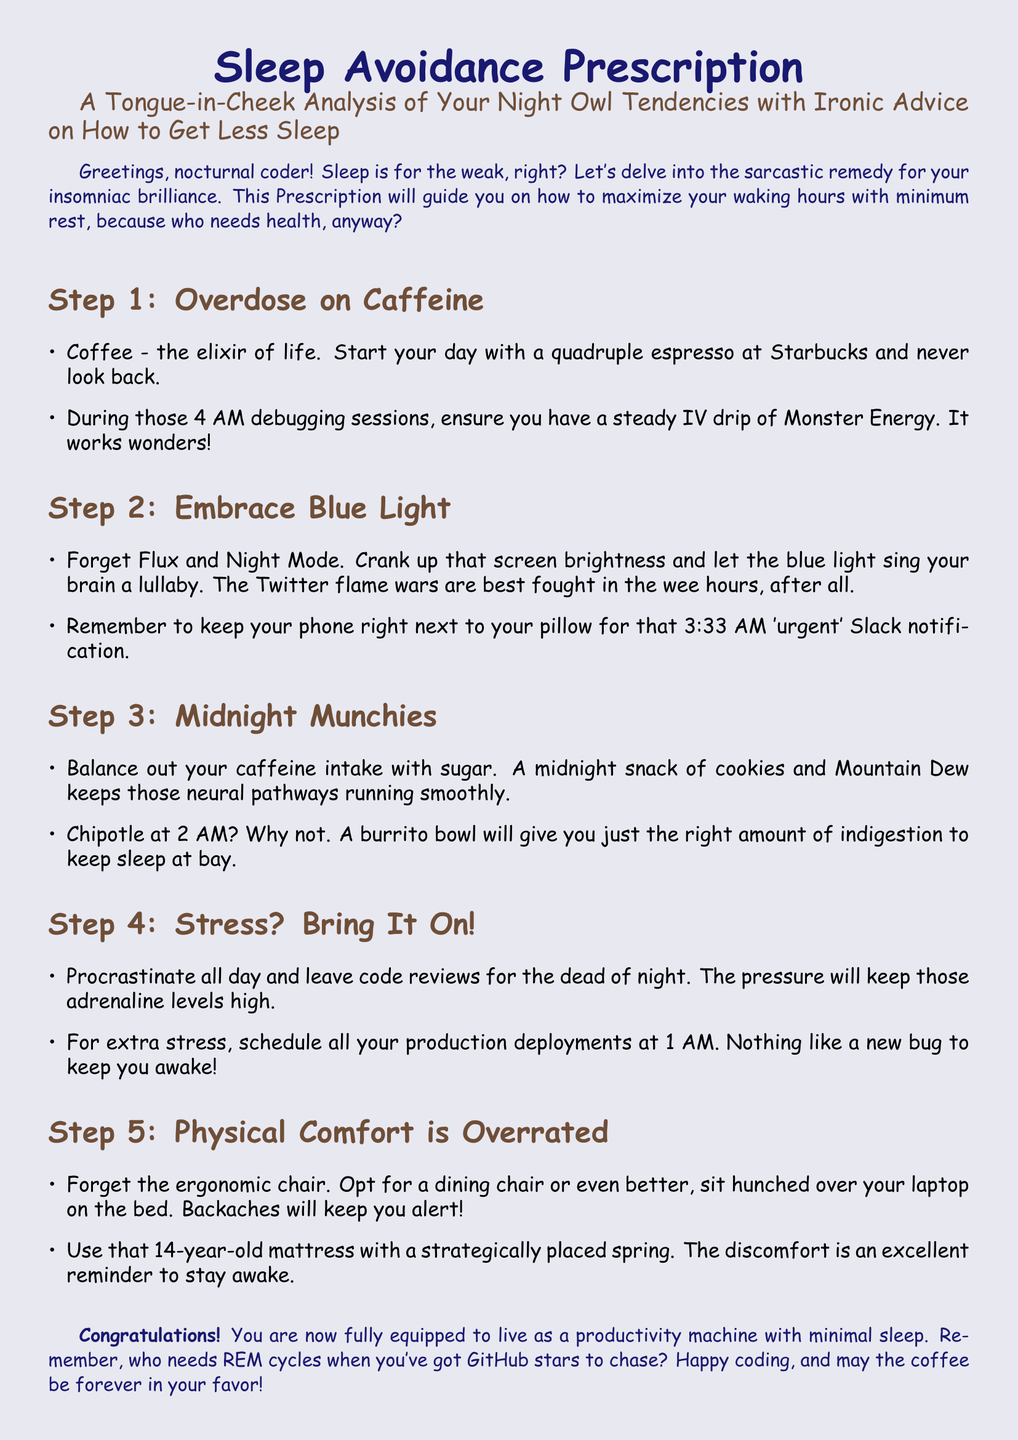What are the steps outlined in the prescription? The document outlines five steps for sleep avoidance: Overdose on Caffeine, Embrace Blue Light, Midnight Munchies, Stress? Bring It On!, and Physical Comfort is Overrated.
Answer: Five steps What is suggested as an ideal drink to start the day? The prescription humorously suggests starting the day with a quadruple espresso at Starbucks.
Answer: Quadruple espresso What type of light should you embrace according to the document? The document sarcastically advises readers to embrace blue light instead of using night mode or blue light filters.
Answer: Blue light What is the recommended midnight snack? The document suggests cookies and Mountain Dew as a midnight snack to balance caffeine intake with sugar.
Answer: Cookies and Mountain Dew When should you schedule production deployments? The ironic advice recommends scheduling production deployments at 1 AM for added stress and to stay awake.
Answer: 1 AM What kind of chair is discouraged for working? The document humorously suggests that ergonomic chairs are overrated and recommends a dining chair instead.
Answer: Dining chair Congratulations! What are you now equipped to be? The document concludes by stating that the reader is fully equipped to live as a productivity machine with minimal sleep.
Answer: Productivity machine What is the humorous consequence of procrastination mentioned? The prescription highlights that procrastinating all day leads to code reviews being left for the dead of night, thereby adding stress.
Answer: Adding stress What is advised to be right next to your pillow? The document suggests keeping your phone right next to your pillow for urgent notifications.
Answer: Phone 